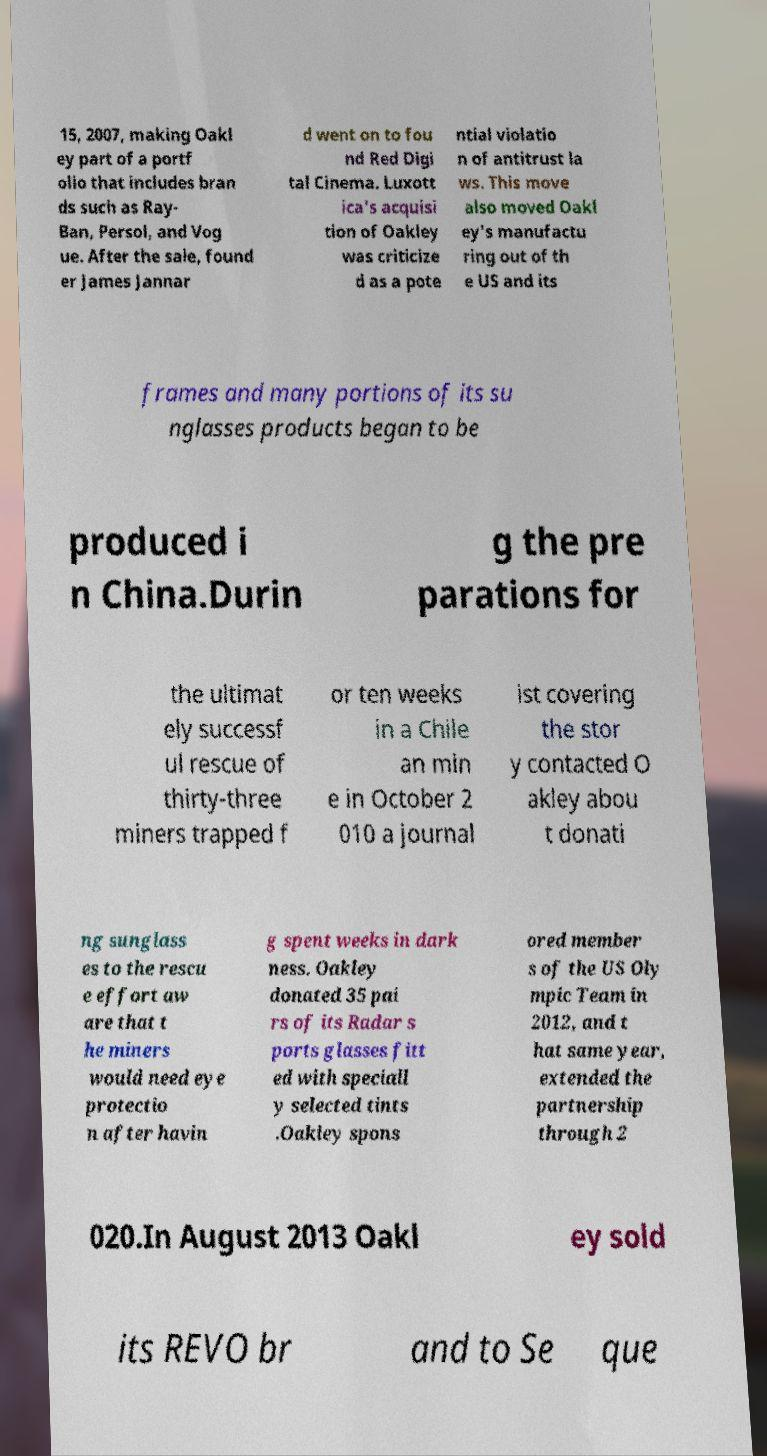Could you extract and type out the text from this image? 15, 2007, making Oakl ey part of a portf olio that includes bran ds such as Ray- Ban, Persol, and Vog ue. After the sale, found er James Jannar d went on to fou nd Red Digi tal Cinema. Luxott ica's acquisi tion of Oakley was criticize d as a pote ntial violatio n of antitrust la ws. This move also moved Oakl ey's manufactu ring out of th e US and its frames and many portions of its su nglasses products began to be produced i n China.Durin g the pre parations for the ultimat ely successf ul rescue of thirty-three miners trapped f or ten weeks in a Chile an min e in October 2 010 a journal ist covering the stor y contacted O akley abou t donati ng sunglass es to the rescu e effort aw are that t he miners would need eye protectio n after havin g spent weeks in dark ness. Oakley donated 35 pai rs of its Radar s ports glasses fitt ed with speciall y selected tints .Oakley spons ored member s of the US Oly mpic Team in 2012, and t hat same year, extended the partnership through 2 020.In August 2013 Oakl ey sold its REVO br and to Se que 